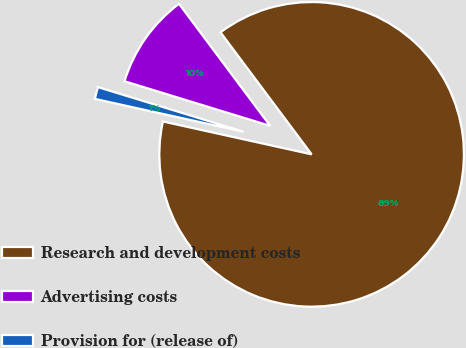<chart> <loc_0><loc_0><loc_500><loc_500><pie_chart><fcel>Research and development costs<fcel>Advertising costs<fcel>Provision for (release of)<nl><fcel>88.67%<fcel>10.06%<fcel>1.27%<nl></chart> 